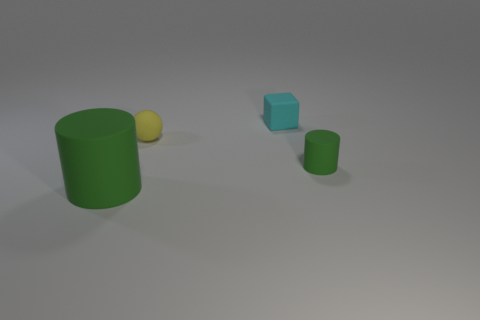Add 1 purple cylinders. How many objects exist? 5 Subtract all balls. How many objects are left? 3 Add 4 small red metal balls. How many small red metal balls exist? 4 Subtract 1 yellow balls. How many objects are left? 3 Subtract all tiny cylinders. Subtract all small cylinders. How many objects are left? 2 Add 3 small yellow matte spheres. How many small yellow matte spheres are left? 4 